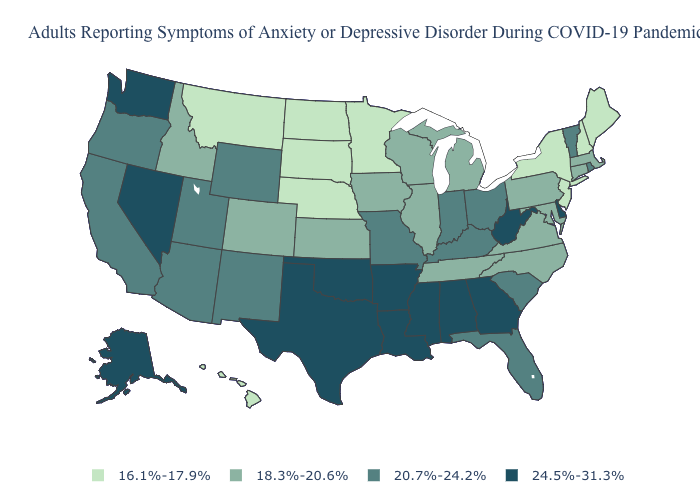What is the value of Idaho?
Quick response, please. 18.3%-20.6%. Which states have the lowest value in the USA?
Be succinct. Hawaii, Maine, Minnesota, Montana, Nebraska, New Hampshire, New Jersey, New York, North Dakota, South Dakota. What is the value of Ohio?
Short answer required. 20.7%-24.2%. Which states have the lowest value in the Northeast?
Short answer required. Maine, New Hampshire, New Jersey, New York. What is the value of Kansas?
Be succinct. 18.3%-20.6%. Does Maine have the lowest value in the USA?
Keep it brief. Yes. Which states hav the highest value in the South?
Write a very short answer. Alabama, Arkansas, Delaware, Georgia, Louisiana, Mississippi, Oklahoma, Texas, West Virginia. Name the states that have a value in the range 24.5%-31.3%?
Be succinct. Alabama, Alaska, Arkansas, Delaware, Georgia, Louisiana, Mississippi, Nevada, Oklahoma, Texas, Washington, West Virginia. What is the lowest value in the USA?
Write a very short answer. 16.1%-17.9%. Does Kansas have the same value as North Carolina?
Quick response, please. Yes. Which states have the highest value in the USA?
Give a very brief answer. Alabama, Alaska, Arkansas, Delaware, Georgia, Louisiana, Mississippi, Nevada, Oklahoma, Texas, Washington, West Virginia. What is the value of Wisconsin?
Keep it brief. 18.3%-20.6%. Which states have the highest value in the USA?
Quick response, please. Alabama, Alaska, Arkansas, Delaware, Georgia, Louisiana, Mississippi, Nevada, Oklahoma, Texas, Washington, West Virginia. What is the value of Georgia?
Short answer required. 24.5%-31.3%. What is the highest value in the USA?
Concise answer only. 24.5%-31.3%. 